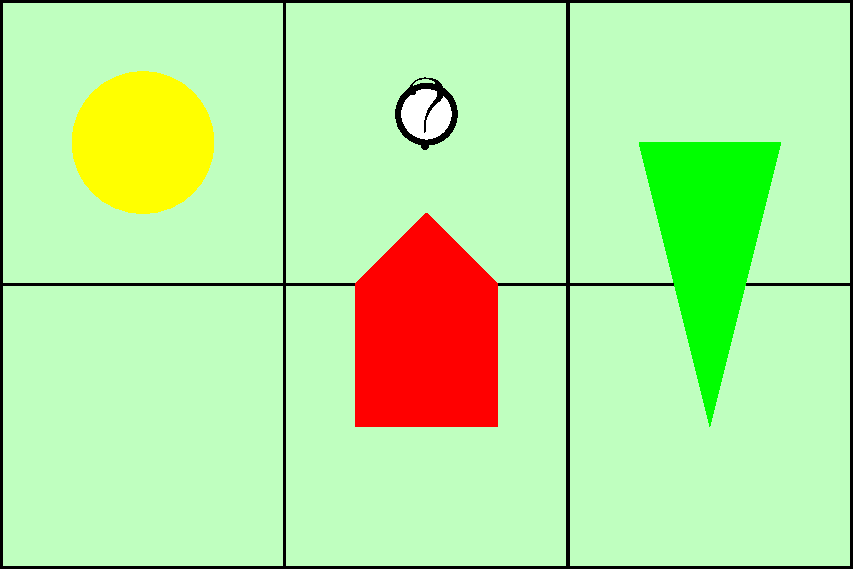In this jigsaw puzzle of a sunny day scene from your favorite cartoon, which piece is missing? To identify the missing piece in this jigsaw puzzle, let's analyze the scene step-by-step:

1. The puzzle is divided into 6 equal-sized pieces in a 3x2 grid.
2. We can see 5 pieces are present, and 1 is missing.
3. The scene depicts:
   - A yellow sun in the top-left corner
   - A green tree in the bottom-right corner
   - A red house in the center-bottom
   - A green background representing grass or a field
4. The missing piece is indicated by a white space with a question mark.
5. This missing piece is located in the top-center of the puzzle.
6. Given its position, the missing piece would likely contain part of the sky and possibly the top of the house or tree.

Based on this analysis, we can conclude that the missing piece is the top-center piece of the puzzle.
Answer: Top-center piece 